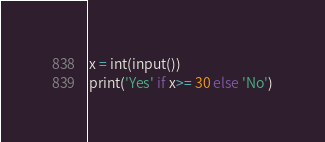<code> <loc_0><loc_0><loc_500><loc_500><_Python_>x = int(input())
print('Yes' if x>= 30 else 'No')
</code> 